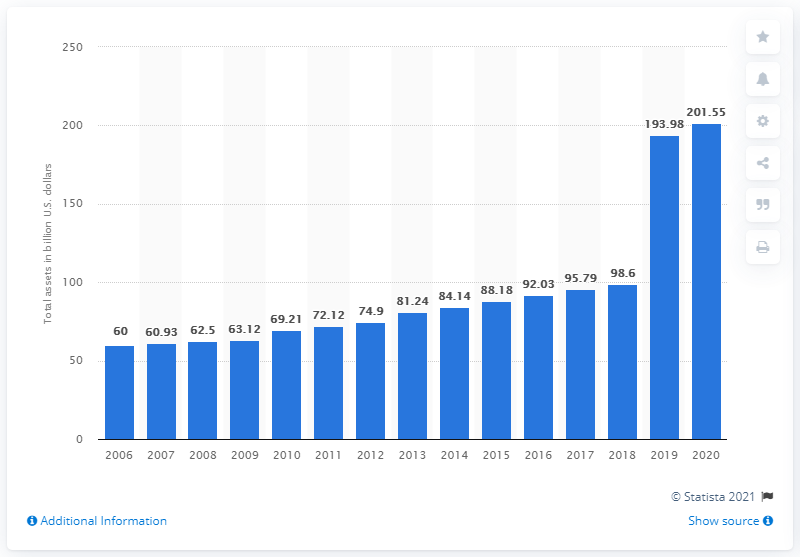Point out several critical features in this image. In 2020, the Walt Disney Company had assets totaling approximately 201.55 billion dollars. 